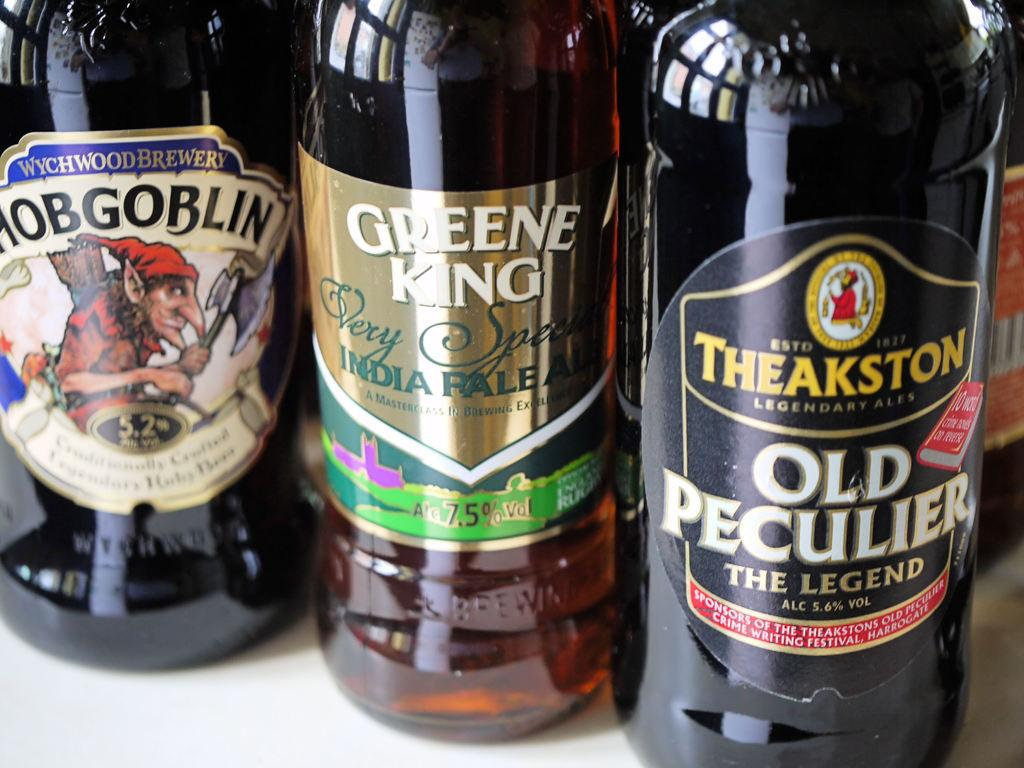<image>
Summarize the visual content of the image. A bottle of Greene King is surrounded by bottles on either side. 